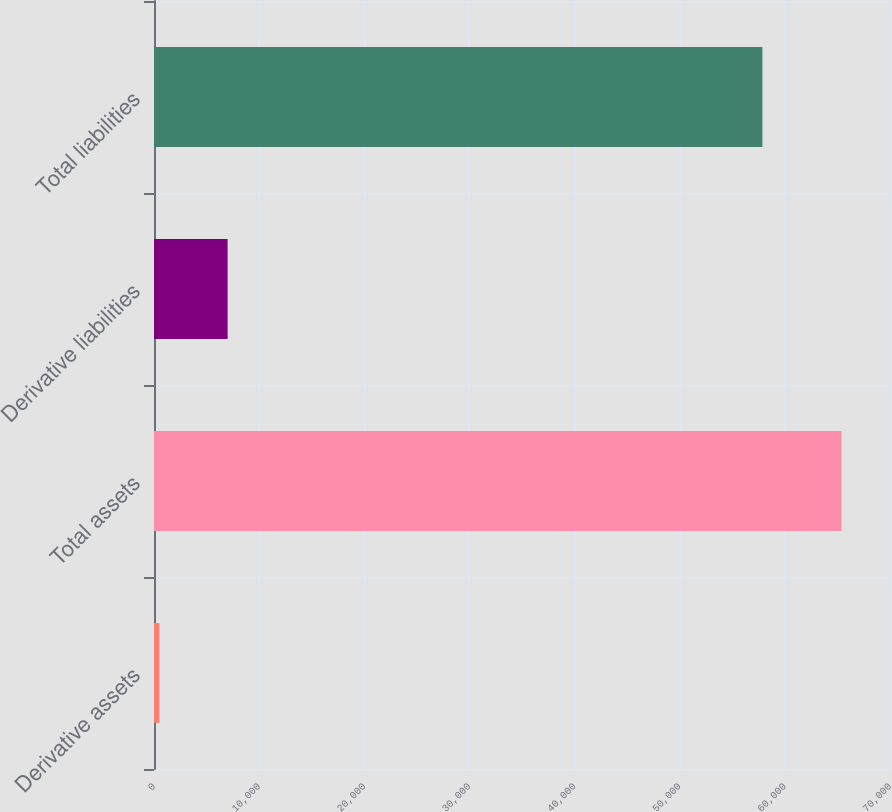<chart> <loc_0><loc_0><loc_500><loc_500><bar_chart><fcel>Derivative assets<fcel>Total assets<fcel>Derivative liabilities<fcel>Total liabilities<nl><fcel>516<fcel>65387<fcel>7003.1<fcel>57865<nl></chart> 